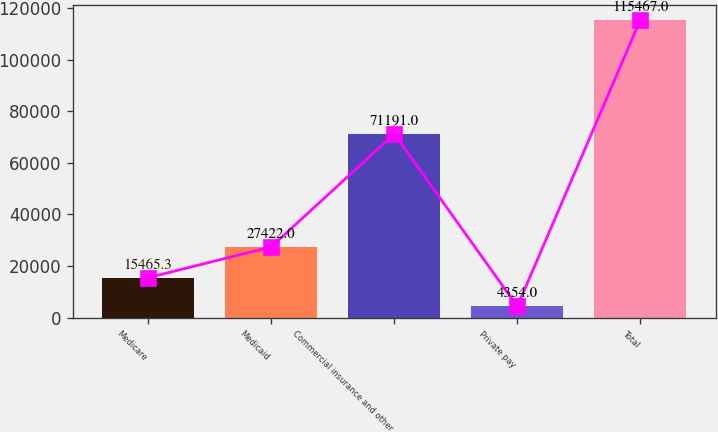Convert chart to OTSL. <chart><loc_0><loc_0><loc_500><loc_500><bar_chart><fcel>Medicare<fcel>Medicaid<fcel>Commercial insurance and other<fcel>Private pay<fcel>Total<nl><fcel>15465.3<fcel>27422<fcel>71191<fcel>4354<fcel>115467<nl></chart> 